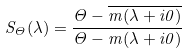<formula> <loc_0><loc_0><loc_500><loc_500>S _ { \Theta } ( \lambda ) = \frac { \Theta - \overline { m ( \lambda + i 0 ) } } { \Theta - m ( \lambda + i 0 ) }</formula> 